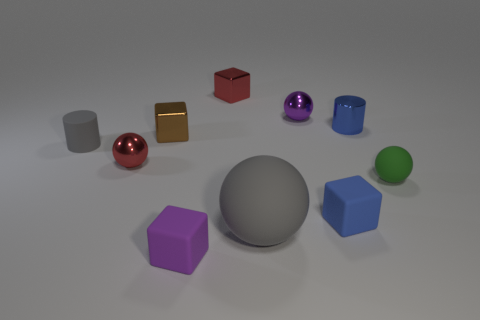How many cylinders are on the right side of the cube that is to the right of the gray rubber ball?
Offer a very short reply. 1. Are there any brown shiny blocks right of the gray rubber ball?
Your answer should be very brief. No. Does the matte thing to the left of the tiny brown shiny thing have the same shape as the small blue shiny object?
Offer a very short reply. Yes. There is a cylinder that is the same color as the big rubber ball; what material is it?
Give a very brief answer. Rubber. What number of other shiny cylinders are the same color as the metallic cylinder?
Keep it short and to the point. 0. The small red metallic thing that is in front of the tiny shiny ball behind the brown shiny cube is what shape?
Offer a very short reply. Sphere. Is there a tiny rubber thing of the same shape as the blue shiny object?
Provide a short and direct response. Yes. Is the color of the big sphere the same as the cylinder in front of the tiny brown thing?
Ensure brevity in your answer.  Yes. There is a rubber ball that is the same color as the small rubber cylinder; what size is it?
Provide a short and direct response. Large. Is there a blue rubber thing of the same size as the purple rubber block?
Your response must be concise. Yes. 